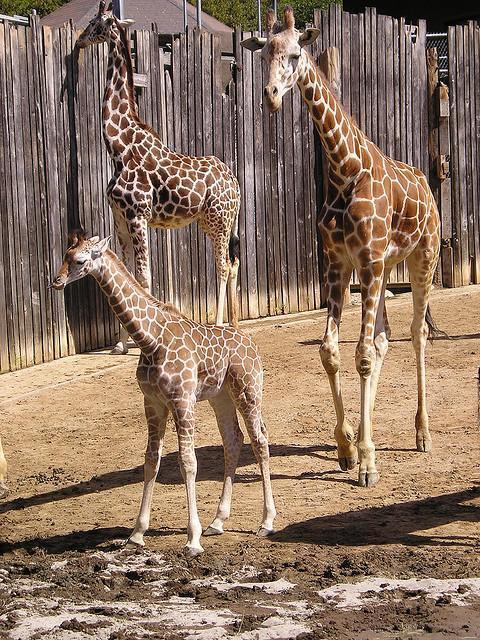How many adult giraffes?
Give a very brief answer. 2. How many giraffes are there?
Give a very brief answer. 3. How many people are touching the motorcycle?
Give a very brief answer. 0. 